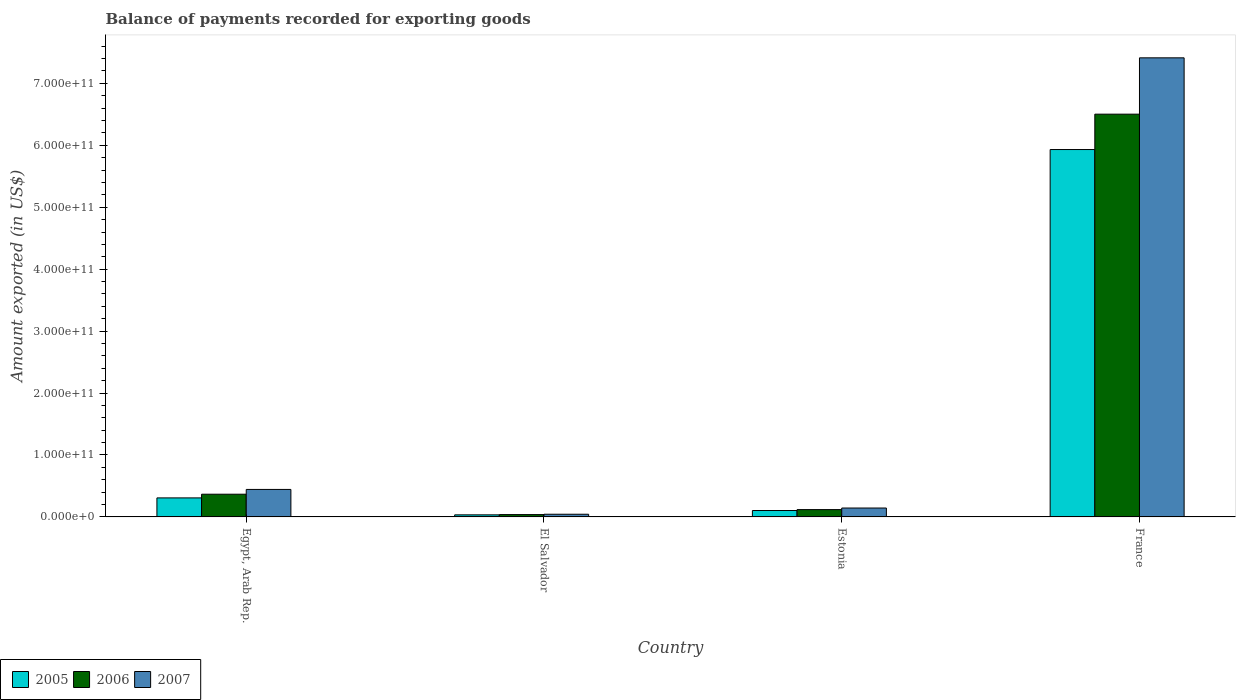How many different coloured bars are there?
Ensure brevity in your answer.  3. How many groups of bars are there?
Keep it short and to the point. 4. What is the label of the 1st group of bars from the left?
Your answer should be very brief. Egypt, Arab Rep. What is the amount exported in 2005 in Estonia?
Provide a succinct answer. 1.04e+1. Across all countries, what is the maximum amount exported in 2005?
Your answer should be compact. 5.93e+11. Across all countries, what is the minimum amount exported in 2005?
Offer a terse response. 3.34e+09. In which country was the amount exported in 2006 maximum?
Give a very brief answer. France. In which country was the amount exported in 2006 minimum?
Provide a short and direct response. El Salvador. What is the total amount exported in 2006 in the graph?
Your answer should be very brief. 7.03e+11. What is the difference between the amount exported in 2007 in Estonia and that in France?
Offer a very short reply. -7.27e+11. What is the difference between the amount exported in 2007 in El Salvador and the amount exported in 2006 in France?
Ensure brevity in your answer.  -6.46e+11. What is the average amount exported in 2007 per country?
Provide a short and direct response. 2.01e+11. What is the difference between the amount exported of/in 2006 and amount exported of/in 2005 in France?
Make the answer very short. 5.71e+1. What is the ratio of the amount exported in 2005 in Estonia to that in France?
Keep it short and to the point. 0.02. What is the difference between the highest and the second highest amount exported in 2007?
Your answer should be compact. 7.27e+11. What is the difference between the highest and the lowest amount exported in 2005?
Your answer should be very brief. 5.90e+11. Is the sum of the amount exported in 2005 in El Salvador and France greater than the maximum amount exported in 2006 across all countries?
Your answer should be compact. No. What does the 3rd bar from the left in Egypt, Arab Rep. represents?
Your answer should be compact. 2007. Is it the case that in every country, the sum of the amount exported in 2005 and amount exported in 2006 is greater than the amount exported in 2007?
Offer a very short reply. Yes. How many bars are there?
Make the answer very short. 12. What is the difference between two consecutive major ticks on the Y-axis?
Offer a very short reply. 1.00e+11. Does the graph contain grids?
Your answer should be compact. No. How many legend labels are there?
Give a very brief answer. 3. What is the title of the graph?
Make the answer very short. Balance of payments recorded for exporting goods. What is the label or title of the Y-axis?
Keep it short and to the point. Amount exported (in US$). What is the Amount exported (in US$) of 2005 in Egypt, Arab Rep.?
Offer a terse response. 3.07e+1. What is the Amount exported (in US$) of 2006 in Egypt, Arab Rep.?
Provide a short and direct response. 3.67e+1. What is the Amount exported (in US$) in 2007 in Egypt, Arab Rep.?
Provide a short and direct response. 4.44e+1. What is the Amount exported (in US$) of 2005 in El Salvador?
Ensure brevity in your answer.  3.34e+09. What is the Amount exported (in US$) in 2006 in El Salvador?
Ensure brevity in your answer.  3.77e+09. What is the Amount exported (in US$) of 2007 in El Salvador?
Your answer should be very brief. 4.35e+09. What is the Amount exported (in US$) of 2005 in Estonia?
Keep it short and to the point. 1.04e+1. What is the Amount exported (in US$) in 2006 in Estonia?
Provide a succinct answer. 1.18e+1. What is the Amount exported (in US$) of 2007 in Estonia?
Offer a terse response. 1.44e+1. What is the Amount exported (in US$) in 2005 in France?
Make the answer very short. 5.93e+11. What is the Amount exported (in US$) in 2006 in France?
Provide a succinct answer. 6.50e+11. What is the Amount exported (in US$) of 2007 in France?
Ensure brevity in your answer.  7.41e+11. Across all countries, what is the maximum Amount exported (in US$) in 2005?
Provide a short and direct response. 5.93e+11. Across all countries, what is the maximum Amount exported (in US$) in 2006?
Keep it short and to the point. 6.50e+11. Across all countries, what is the maximum Amount exported (in US$) in 2007?
Your response must be concise. 7.41e+11. Across all countries, what is the minimum Amount exported (in US$) of 2005?
Ensure brevity in your answer.  3.34e+09. Across all countries, what is the minimum Amount exported (in US$) of 2006?
Offer a terse response. 3.77e+09. Across all countries, what is the minimum Amount exported (in US$) in 2007?
Offer a terse response. 4.35e+09. What is the total Amount exported (in US$) of 2005 in the graph?
Provide a succinct answer. 6.38e+11. What is the total Amount exported (in US$) in 2006 in the graph?
Give a very brief answer. 7.03e+11. What is the total Amount exported (in US$) in 2007 in the graph?
Your response must be concise. 8.04e+11. What is the difference between the Amount exported (in US$) in 2005 in Egypt, Arab Rep. and that in El Salvador?
Make the answer very short. 2.74e+1. What is the difference between the Amount exported (in US$) in 2006 in Egypt, Arab Rep. and that in El Salvador?
Offer a terse response. 3.29e+1. What is the difference between the Amount exported (in US$) in 2007 in Egypt, Arab Rep. and that in El Salvador?
Offer a terse response. 4.00e+1. What is the difference between the Amount exported (in US$) in 2005 in Egypt, Arab Rep. and that in Estonia?
Ensure brevity in your answer.  2.03e+1. What is the difference between the Amount exported (in US$) of 2006 in Egypt, Arab Rep. and that in Estonia?
Ensure brevity in your answer.  2.48e+1. What is the difference between the Amount exported (in US$) of 2007 in Egypt, Arab Rep. and that in Estonia?
Ensure brevity in your answer.  3.00e+1. What is the difference between the Amount exported (in US$) of 2005 in Egypt, Arab Rep. and that in France?
Provide a short and direct response. -5.62e+11. What is the difference between the Amount exported (in US$) of 2006 in Egypt, Arab Rep. and that in France?
Ensure brevity in your answer.  -6.14e+11. What is the difference between the Amount exported (in US$) of 2007 in Egypt, Arab Rep. and that in France?
Your answer should be compact. -6.97e+11. What is the difference between the Amount exported (in US$) in 2005 in El Salvador and that in Estonia?
Provide a short and direct response. -7.03e+09. What is the difference between the Amount exported (in US$) in 2006 in El Salvador and that in Estonia?
Your answer should be very brief. -8.06e+09. What is the difference between the Amount exported (in US$) in 2007 in El Salvador and that in Estonia?
Give a very brief answer. -1.00e+1. What is the difference between the Amount exported (in US$) of 2005 in El Salvador and that in France?
Make the answer very short. -5.90e+11. What is the difference between the Amount exported (in US$) of 2006 in El Salvador and that in France?
Ensure brevity in your answer.  -6.47e+11. What is the difference between the Amount exported (in US$) of 2007 in El Salvador and that in France?
Make the answer very short. -7.37e+11. What is the difference between the Amount exported (in US$) in 2005 in Estonia and that in France?
Give a very brief answer. -5.83e+11. What is the difference between the Amount exported (in US$) in 2006 in Estonia and that in France?
Make the answer very short. -6.38e+11. What is the difference between the Amount exported (in US$) in 2007 in Estonia and that in France?
Your response must be concise. -7.27e+11. What is the difference between the Amount exported (in US$) in 2005 in Egypt, Arab Rep. and the Amount exported (in US$) in 2006 in El Salvador?
Your answer should be very brief. 2.69e+1. What is the difference between the Amount exported (in US$) in 2005 in Egypt, Arab Rep. and the Amount exported (in US$) in 2007 in El Salvador?
Offer a terse response. 2.64e+1. What is the difference between the Amount exported (in US$) in 2006 in Egypt, Arab Rep. and the Amount exported (in US$) in 2007 in El Salvador?
Keep it short and to the point. 3.23e+1. What is the difference between the Amount exported (in US$) of 2005 in Egypt, Arab Rep. and the Amount exported (in US$) of 2006 in Estonia?
Ensure brevity in your answer.  1.89e+1. What is the difference between the Amount exported (in US$) of 2005 in Egypt, Arab Rep. and the Amount exported (in US$) of 2007 in Estonia?
Make the answer very short. 1.63e+1. What is the difference between the Amount exported (in US$) in 2006 in Egypt, Arab Rep. and the Amount exported (in US$) in 2007 in Estonia?
Ensure brevity in your answer.  2.23e+1. What is the difference between the Amount exported (in US$) of 2005 in Egypt, Arab Rep. and the Amount exported (in US$) of 2006 in France?
Your answer should be compact. -6.20e+11. What is the difference between the Amount exported (in US$) of 2005 in Egypt, Arab Rep. and the Amount exported (in US$) of 2007 in France?
Your response must be concise. -7.11e+11. What is the difference between the Amount exported (in US$) of 2006 in Egypt, Arab Rep. and the Amount exported (in US$) of 2007 in France?
Provide a succinct answer. -7.05e+11. What is the difference between the Amount exported (in US$) in 2005 in El Salvador and the Amount exported (in US$) in 2006 in Estonia?
Provide a short and direct response. -8.49e+09. What is the difference between the Amount exported (in US$) of 2005 in El Salvador and the Amount exported (in US$) of 2007 in Estonia?
Keep it short and to the point. -1.10e+1. What is the difference between the Amount exported (in US$) in 2006 in El Salvador and the Amount exported (in US$) in 2007 in Estonia?
Give a very brief answer. -1.06e+1. What is the difference between the Amount exported (in US$) of 2005 in El Salvador and the Amount exported (in US$) of 2006 in France?
Provide a short and direct response. -6.47e+11. What is the difference between the Amount exported (in US$) of 2005 in El Salvador and the Amount exported (in US$) of 2007 in France?
Your answer should be very brief. -7.38e+11. What is the difference between the Amount exported (in US$) of 2006 in El Salvador and the Amount exported (in US$) of 2007 in France?
Keep it short and to the point. -7.37e+11. What is the difference between the Amount exported (in US$) of 2005 in Estonia and the Amount exported (in US$) of 2006 in France?
Provide a short and direct response. -6.40e+11. What is the difference between the Amount exported (in US$) in 2005 in Estonia and the Amount exported (in US$) in 2007 in France?
Keep it short and to the point. -7.31e+11. What is the difference between the Amount exported (in US$) of 2006 in Estonia and the Amount exported (in US$) of 2007 in France?
Ensure brevity in your answer.  -7.29e+11. What is the average Amount exported (in US$) of 2005 per country?
Your answer should be very brief. 1.59e+11. What is the average Amount exported (in US$) of 2006 per country?
Your answer should be very brief. 1.76e+11. What is the average Amount exported (in US$) in 2007 per country?
Your answer should be very brief. 2.01e+11. What is the difference between the Amount exported (in US$) in 2005 and Amount exported (in US$) in 2006 in Egypt, Arab Rep.?
Give a very brief answer. -5.96e+09. What is the difference between the Amount exported (in US$) in 2005 and Amount exported (in US$) in 2007 in Egypt, Arab Rep.?
Provide a succinct answer. -1.37e+1. What is the difference between the Amount exported (in US$) in 2006 and Amount exported (in US$) in 2007 in Egypt, Arab Rep.?
Keep it short and to the point. -7.72e+09. What is the difference between the Amount exported (in US$) in 2005 and Amount exported (in US$) in 2006 in El Salvador?
Your response must be concise. -4.29e+08. What is the difference between the Amount exported (in US$) in 2005 and Amount exported (in US$) in 2007 in El Salvador?
Your answer should be compact. -1.01e+09. What is the difference between the Amount exported (in US$) of 2006 and Amount exported (in US$) of 2007 in El Salvador?
Your answer should be compact. -5.79e+08. What is the difference between the Amount exported (in US$) of 2005 and Amount exported (in US$) of 2006 in Estonia?
Your answer should be very brief. -1.46e+09. What is the difference between the Amount exported (in US$) of 2005 and Amount exported (in US$) of 2007 in Estonia?
Make the answer very short. -4.01e+09. What is the difference between the Amount exported (in US$) of 2006 and Amount exported (in US$) of 2007 in Estonia?
Your response must be concise. -2.55e+09. What is the difference between the Amount exported (in US$) in 2005 and Amount exported (in US$) in 2006 in France?
Offer a very short reply. -5.71e+1. What is the difference between the Amount exported (in US$) in 2005 and Amount exported (in US$) in 2007 in France?
Provide a succinct answer. -1.48e+11. What is the difference between the Amount exported (in US$) in 2006 and Amount exported (in US$) in 2007 in France?
Offer a terse response. -9.10e+1. What is the ratio of the Amount exported (in US$) in 2005 in Egypt, Arab Rep. to that in El Salvador?
Provide a short and direct response. 9.19. What is the ratio of the Amount exported (in US$) of 2006 in Egypt, Arab Rep. to that in El Salvador?
Your answer should be very brief. 9.73. What is the ratio of the Amount exported (in US$) in 2007 in Egypt, Arab Rep. to that in El Salvador?
Give a very brief answer. 10.21. What is the ratio of the Amount exported (in US$) of 2005 in Egypt, Arab Rep. to that in Estonia?
Make the answer very short. 2.96. What is the ratio of the Amount exported (in US$) in 2006 in Egypt, Arab Rep. to that in Estonia?
Offer a terse response. 3.1. What is the ratio of the Amount exported (in US$) in 2007 in Egypt, Arab Rep. to that in Estonia?
Your answer should be very brief. 3.09. What is the ratio of the Amount exported (in US$) in 2005 in Egypt, Arab Rep. to that in France?
Offer a very short reply. 0.05. What is the ratio of the Amount exported (in US$) of 2006 in Egypt, Arab Rep. to that in France?
Provide a short and direct response. 0.06. What is the ratio of the Amount exported (in US$) in 2007 in Egypt, Arab Rep. to that in France?
Your answer should be very brief. 0.06. What is the ratio of the Amount exported (in US$) in 2005 in El Salvador to that in Estonia?
Ensure brevity in your answer.  0.32. What is the ratio of the Amount exported (in US$) of 2006 in El Salvador to that in Estonia?
Give a very brief answer. 0.32. What is the ratio of the Amount exported (in US$) in 2007 in El Salvador to that in Estonia?
Make the answer very short. 0.3. What is the ratio of the Amount exported (in US$) in 2005 in El Salvador to that in France?
Make the answer very short. 0.01. What is the ratio of the Amount exported (in US$) in 2006 in El Salvador to that in France?
Provide a short and direct response. 0.01. What is the ratio of the Amount exported (in US$) of 2007 in El Salvador to that in France?
Your response must be concise. 0.01. What is the ratio of the Amount exported (in US$) in 2005 in Estonia to that in France?
Your answer should be very brief. 0.02. What is the ratio of the Amount exported (in US$) of 2006 in Estonia to that in France?
Give a very brief answer. 0.02. What is the ratio of the Amount exported (in US$) in 2007 in Estonia to that in France?
Your response must be concise. 0.02. What is the difference between the highest and the second highest Amount exported (in US$) in 2005?
Your answer should be very brief. 5.62e+11. What is the difference between the highest and the second highest Amount exported (in US$) of 2006?
Make the answer very short. 6.14e+11. What is the difference between the highest and the second highest Amount exported (in US$) in 2007?
Your answer should be compact. 6.97e+11. What is the difference between the highest and the lowest Amount exported (in US$) in 2005?
Your response must be concise. 5.90e+11. What is the difference between the highest and the lowest Amount exported (in US$) of 2006?
Your response must be concise. 6.47e+11. What is the difference between the highest and the lowest Amount exported (in US$) in 2007?
Give a very brief answer. 7.37e+11. 